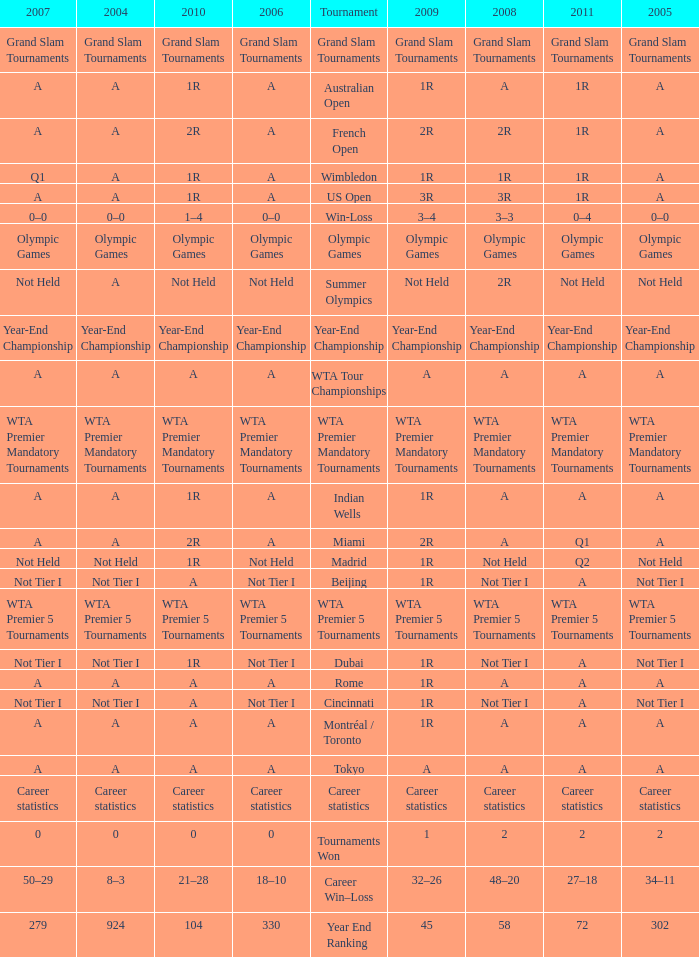What is 2010, when 2009 is "1"? 0.0. 